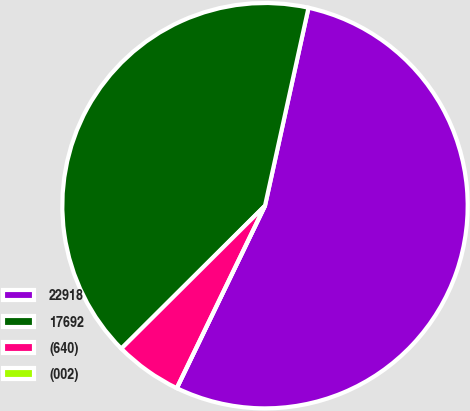Convert chart. <chart><loc_0><loc_0><loc_500><loc_500><pie_chart><fcel>22918<fcel>17692<fcel>(640)<fcel>(002)<nl><fcel>53.72%<fcel>40.9%<fcel>5.37%<fcel>0.0%<nl></chart> 